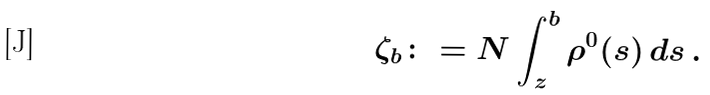Convert formula to latex. <formula><loc_0><loc_0><loc_500><loc_500>\zeta _ { b } \colon = N \int _ { z } ^ { b } \rho ^ { 0 } ( s ) \, d s \, .</formula> 